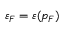Convert formula to latex. <formula><loc_0><loc_0><loc_500><loc_500>\varepsilon _ { F } = \varepsilon ( p _ { F } )</formula> 